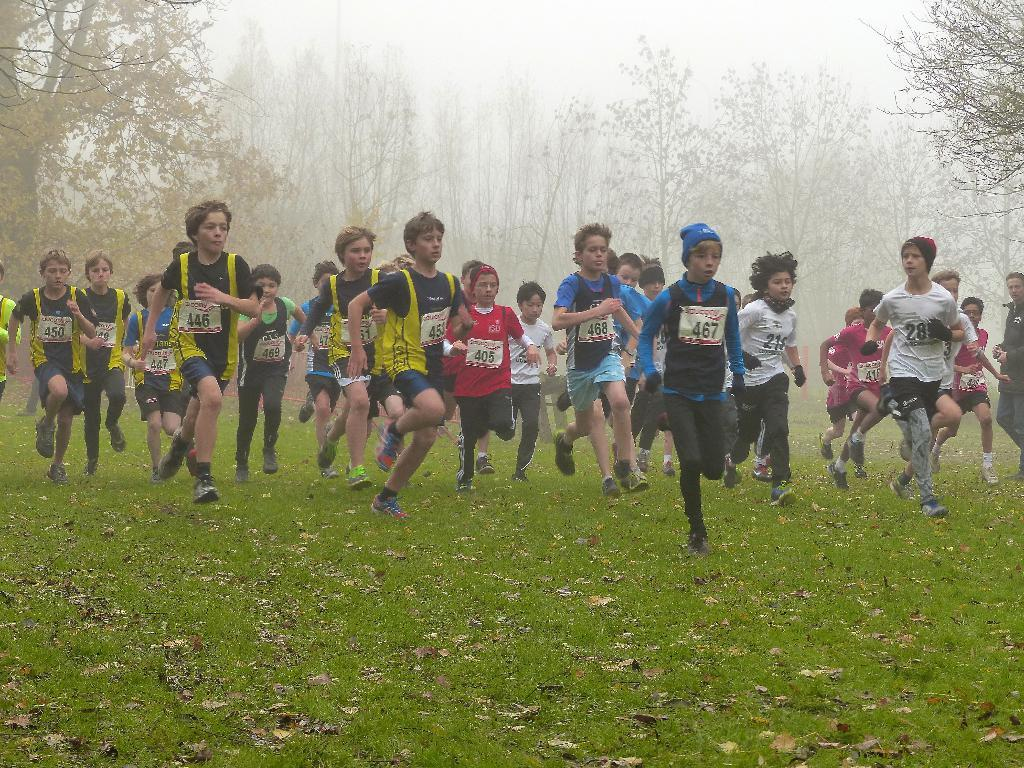What is the main subject of the image? The main subject of the image is a group of children. What are the children doing in the image? The children are running on a grass surface. What are the children wearing in the image? The children are wearing sportswear. What can be seen in the background of the image? There are trees and fog visible in the background of the image. How many sisters are present in the image? There is no mention of sisters in the image, as it features a group of children running on a grass surface. 